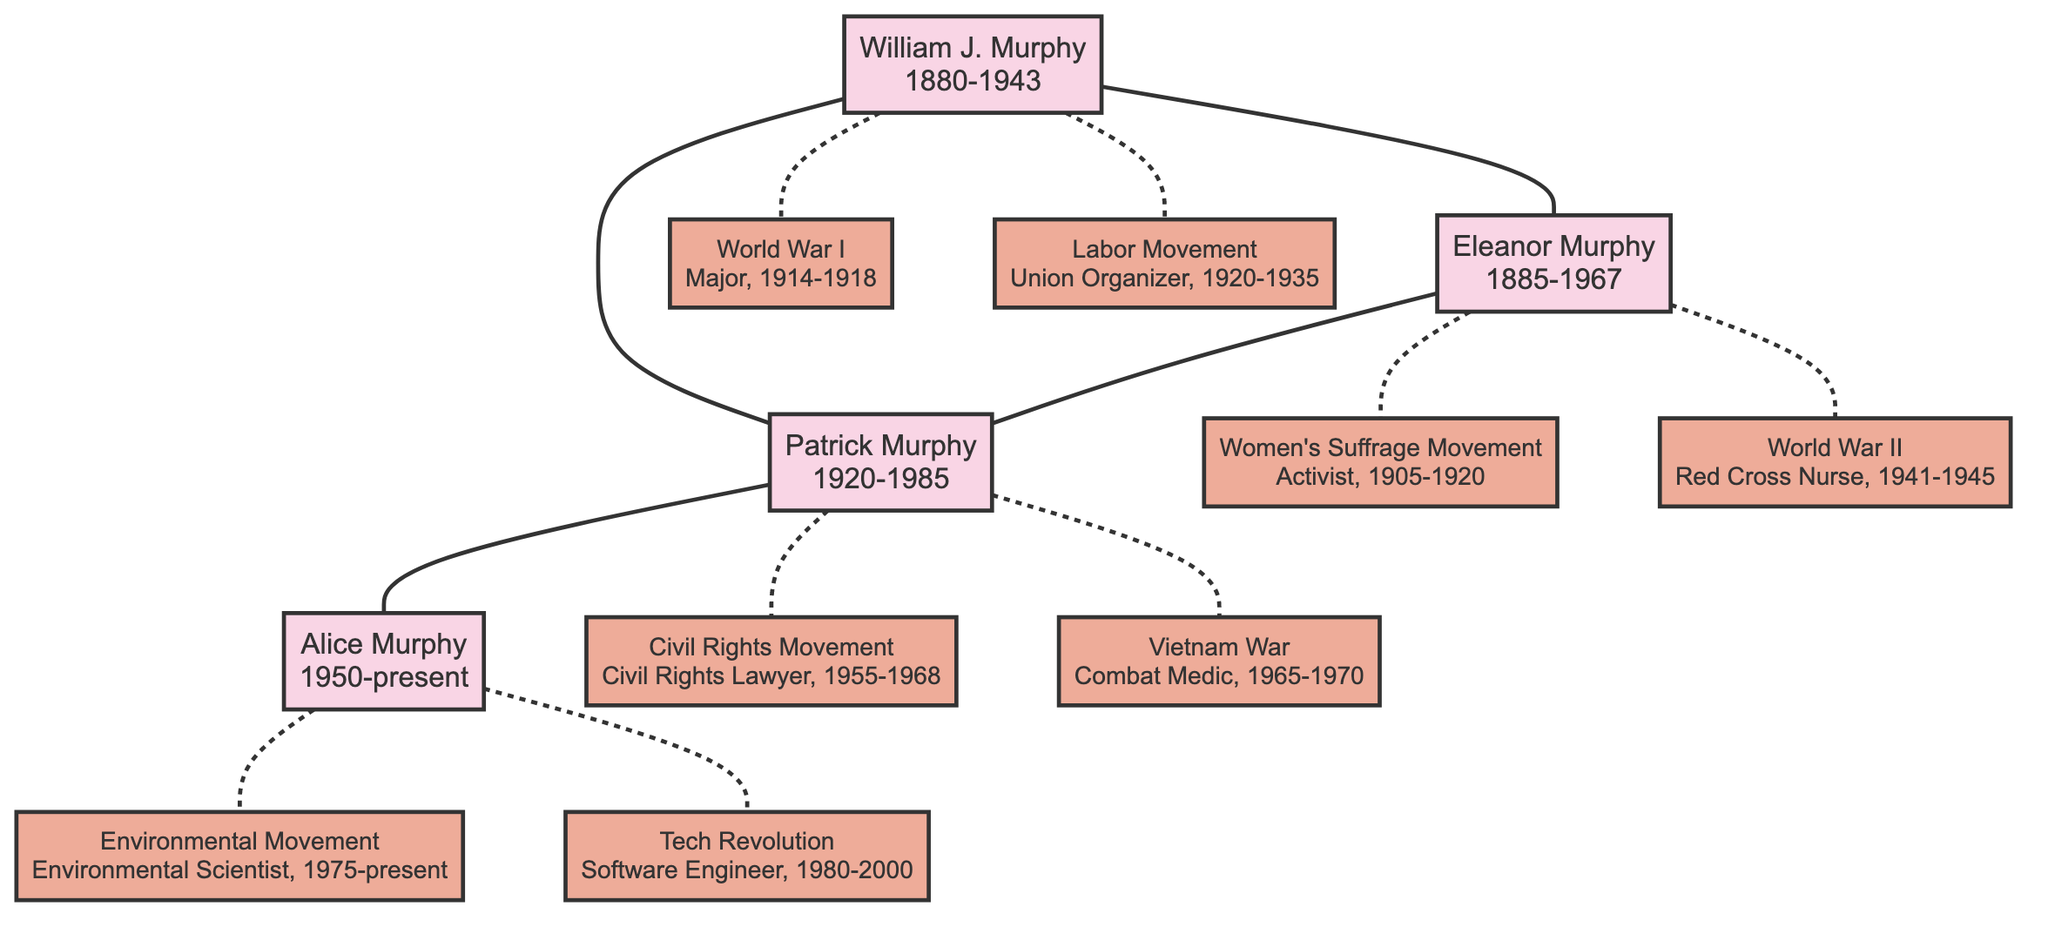What is the birth year of William J. Murphy? From the diagram, William J. Murphy's node states his date of birth as 1880-05-15. The birth year can be extracted from this date.
Answer: 1880 Which historical event did Patrick Murphy participate in related to legal rights? The diagram shows that Patrick Murphy was involved in the Civil Rights Movement as a Civil Rights Lawyer from 1955 to 1968. This indicates his participation was in legal rights efforts during this period.
Answer: Civil Rights Movement How many events are associated with Eleanor Murphy? Eleanor Murphy's node lists two distinct events: the Women's Suffrage Movement and World War II. By counting these events, we can determine the total.
Answer: 2 What role did Alice Murphy play in the Environmental Movement? The diagram indicates that Alice Murphy's role in the Environmental Movement is that of an Environmental Scientist. This specific information is found directly on her associated event.
Answer: Environmental Scientist Who is the parent of Patrick Murphy? The diagram shows a direct connection between William J. Murphy and Eleanor Murphy as parents of Patrick Murphy. Therefore, either of them can be identified as his parent.
Answer: William J. Murphy and Eleanor Murphy In which year range did William J. Murphy serve in World War I? The diagram specifies that William J. Murphy's participation in World War I was as a Major from 1914 to 1918. These years indicate the duration of his service.
Answer: 1914-1918 Which member of the Murphy family is involved in the Tech Revolution? According to the diagram, Alice Murphy is the family member depicted as involved in the Tech Revolution with her role outlined as a Software Engineer.
Answer: Alice Murphy What connection exists between Patrick Murphy and the Vietnam War? The diagram indicates that Patrick Murphy served as a Combat Medic during the Vietnam War from 1965 to 1970, establishing a direct participation link.
Answer: Combat Medic How are William J. Murphy and Eleanor Murphy related? The diagram shows a direct connection between William J. Murphy and Eleanor Murphy as spouses who jointly parented Patrick Murphy.
Answer: Spouses 